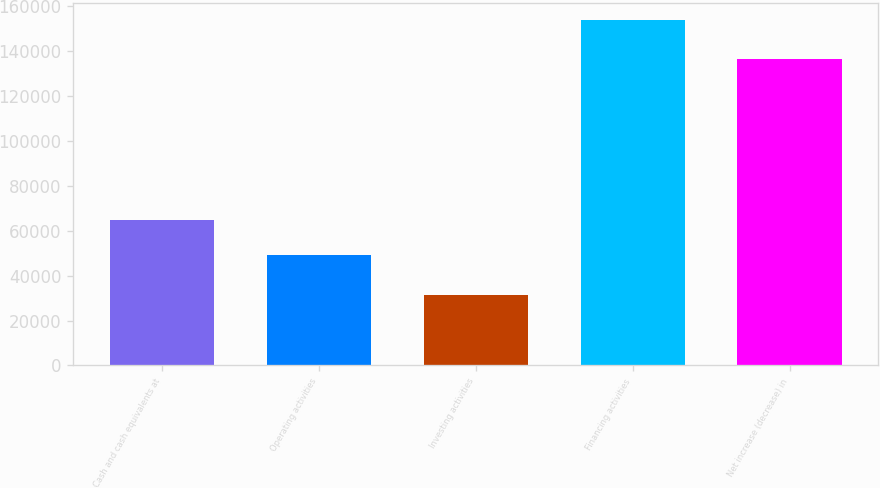Convert chart to OTSL. <chart><loc_0><loc_0><loc_500><loc_500><bar_chart><fcel>Cash and cash equivalents at<fcel>Operating activities<fcel>Investing activities<fcel>Financing activities<fcel>Net increase (decrease) in<nl><fcel>64928<fcel>48965<fcel>31561<fcel>153609<fcel>136205<nl></chart> 